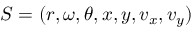<formula> <loc_0><loc_0><loc_500><loc_500>S = ( r , \omega , \theta , x , y , v _ { x } , v _ { y } )</formula> 